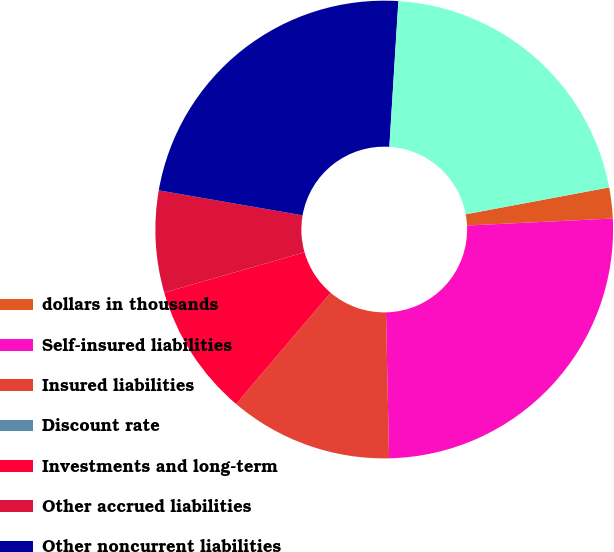Convert chart to OTSL. <chart><loc_0><loc_0><loc_500><loc_500><pie_chart><fcel>dollars in thousands<fcel>Self-insured liabilities<fcel>Insured liabilities<fcel>Discount rate<fcel>Investments and long-term<fcel>Other accrued liabilities<fcel>Other noncurrent liabilities<fcel>Net liabilities (discounted)<nl><fcel>2.18%<fcel>25.43%<fcel>11.54%<fcel>0.0%<fcel>9.36%<fcel>7.18%<fcel>23.25%<fcel>21.07%<nl></chart> 